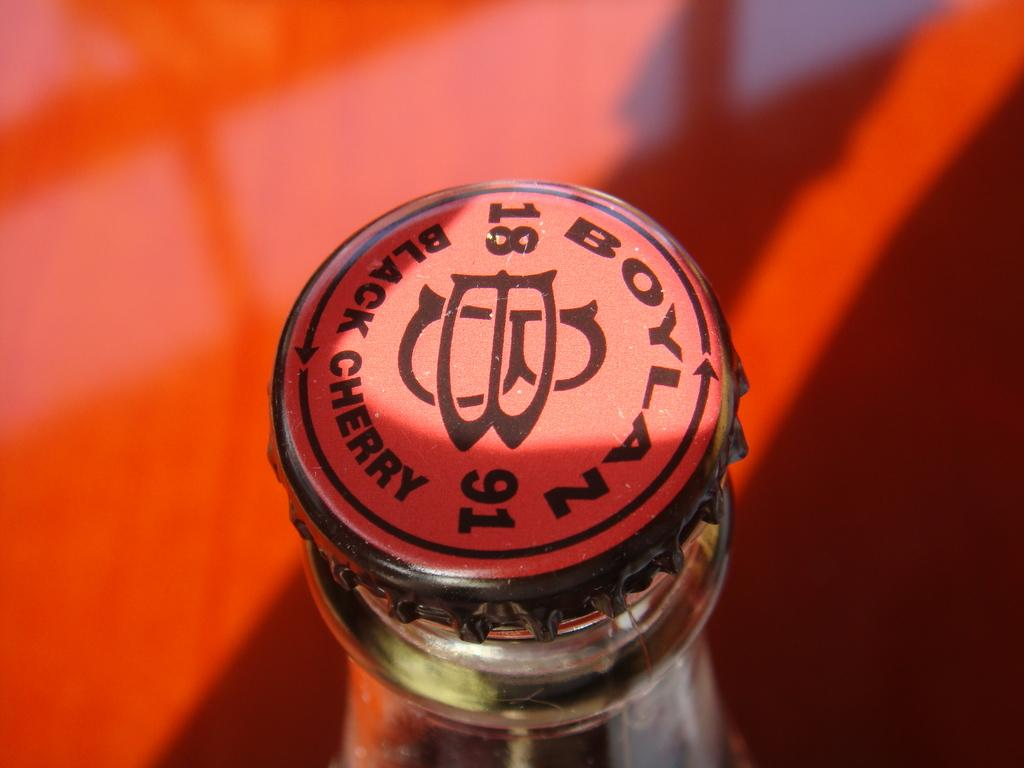<image>
Share a concise interpretation of the image provided. A bottle showing the cap that says Boylan Black 